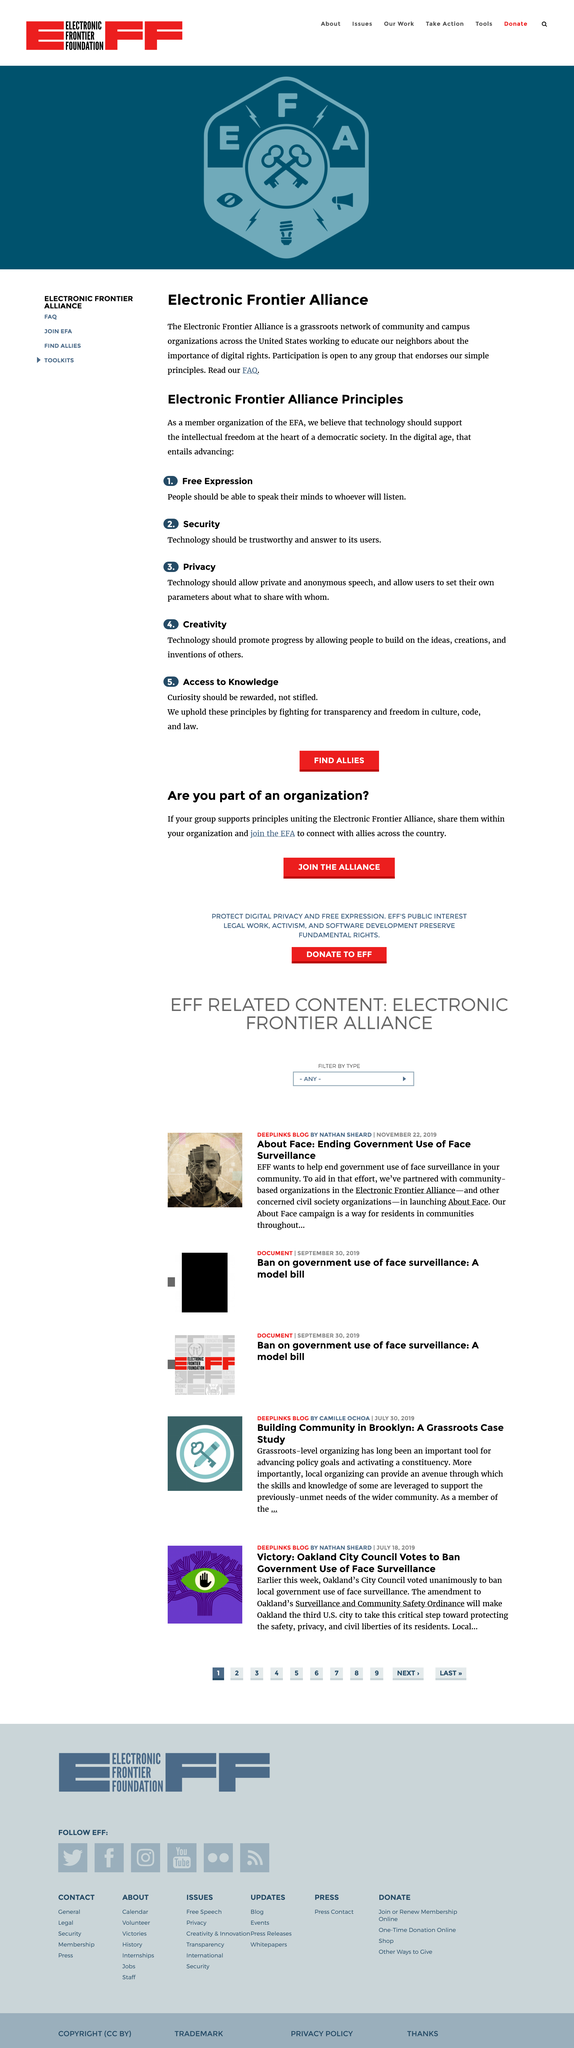Highlight a few significant elements in this photo. I, [your name], declare that Principle One of the Electronic Frontier Alliance Principles is Free Expression, which promotes the free flow of information and ideas online. Privacy is essential for individuals to freely express themselves and maintain their autonomy. Technology should enable private, anonymous speech and allow users to determine what information they choose to share with whom. We, at company X, promote curiosity by upholding the principles of transparency, freedom in culture, code, and law, in order to foster a culture of curiosity and innovation. The Electronic Frontier Alliance is a network of community and campus organizations across the United States working to educate citizens about the importance of digital rights and the need to protect them. Technology should be trustworthy and answer to its users' needs and values. 